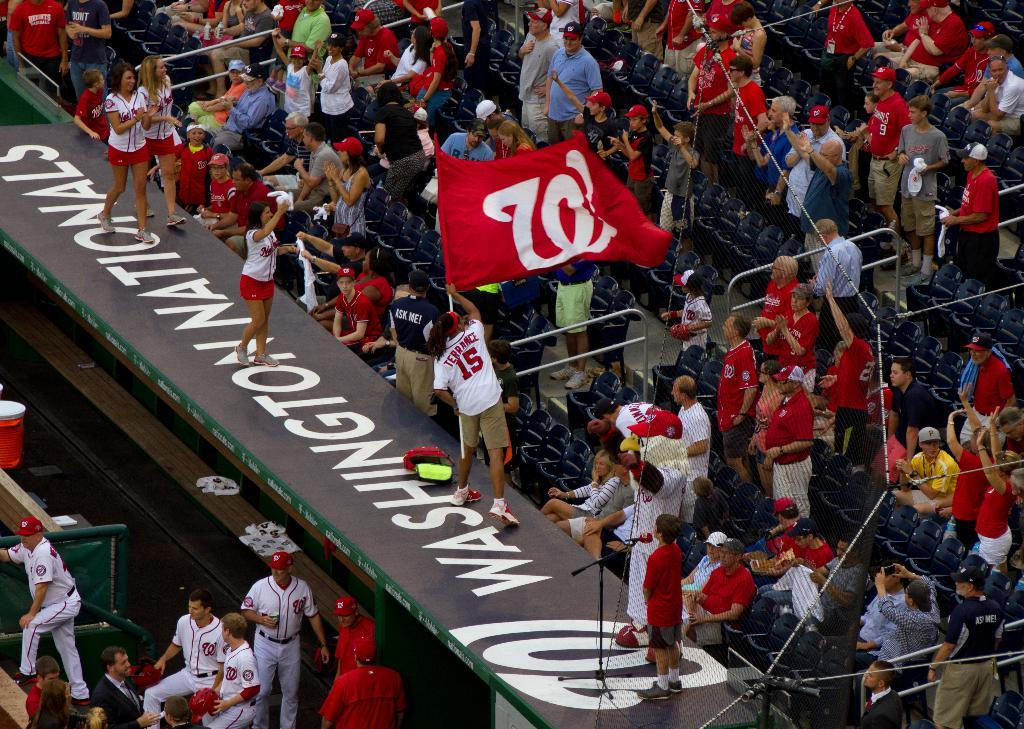<image>
Summarize the visual content of the image. Washington Nationals contain people in the bleachers for a baseball game 